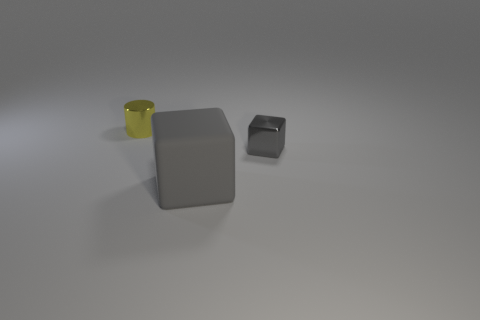Add 1 large matte things. How many objects exist? 4 Subtract all cyan cylinders. Subtract all blue cubes. How many cylinders are left? 1 Subtract all big things. Subtract all small cyan rubber cubes. How many objects are left? 2 Add 1 cylinders. How many cylinders are left? 2 Add 1 tiny gray metal blocks. How many tiny gray metal blocks exist? 2 Subtract 0 purple cylinders. How many objects are left? 3 Subtract all blocks. How many objects are left? 1 Subtract 1 cubes. How many cubes are left? 1 